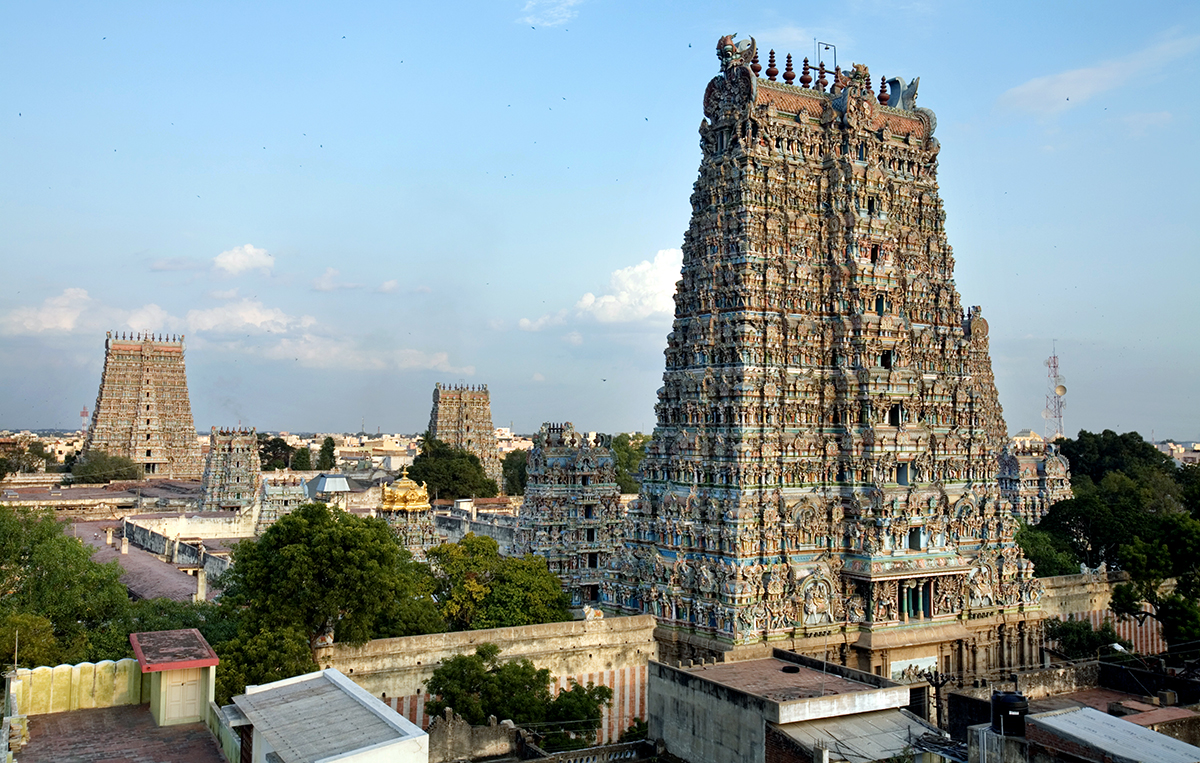How does this temple reflect the cultural fusion of the city? The Meenakshi Amman Temple exemplifies cultural fusion by blending religious tradition with the evolving urban landscape of Madurai. While the temple itself is rooted in age-old religious practices, it stands amid a backdrop of modern buildings, exemplifying how heritage and modernity coexist in Indian cities. This juxtaposition not only highlights the adaptability of cultural traditions amidst modern lifestyles but also symbolizes the seamless integration of historical sanctity within a bustling city environment. 